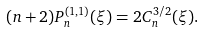<formula> <loc_0><loc_0><loc_500><loc_500>( n + 2 ) P _ { n } ^ { ( 1 , 1 ) } ( \xi ) = 2 C _ { n } ^ { 3 / 2 } ( \xi ) .</formula> 